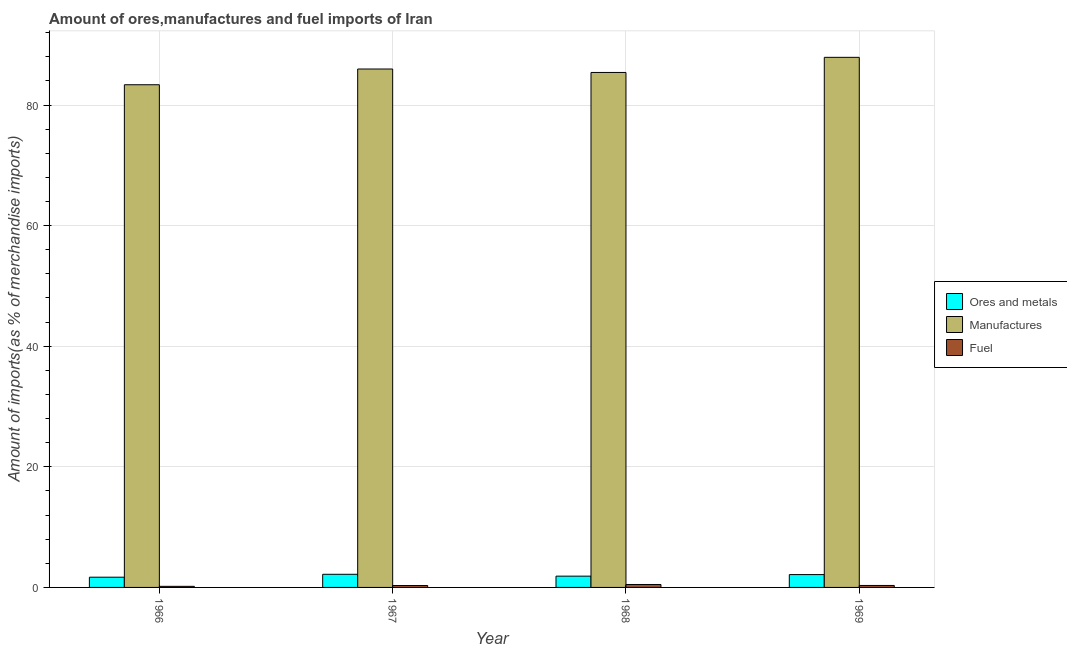How many different coloured bars are there?
Keep it short and to the point. 3. How many bars are there on the 2nd tick from the left?
Your response must be concise. 3. How many bars are there on the 4th tick from the right?
Give a very brief answer. 3. What is the label of the 4th group of bars from the left?
Ensure brevity in your answer.  1969. In how many cases, is the number of bars for a given year not equal to the number of legend labels?
Offer a terse response. 0. What is the percentage of ores and metals imports in 1969?
Ensure brevity in your answer.  2.13. Across all years, what is the maximum percentage of manufactures imports?
Ensure brevity in your answer.  87.91. Across all years, what is the minimum percentage of manufactures imports?
Ensure brevity in your answer.  83.36. In which year was the percentage of fuel imports maximum?
Provide a succinct answer. 1968. In which year was the percentage of manufactures imports minimum?
Your answer should be compact. 1966. What is the total percentage of fuel imports in the graph?
Your answer should be very brief. 1.31. What is the difference between the percentage of ores and metals imports in 1967 and that in 1969?
Make the answer very short. 0.05. What is the difference between the percentage of ores and metals imports in 1967 and the percentage of fuel imports in 1969?
Offer a very short reply. 0.05. What is the average percentage of fuel imports per year?
Give a very brief answer. 0.33. In the year 1966, what is the difference between the percentage of ores and metals imports and percentage of fuel imports?
Ensure brevity in your answer.  0. In how many years, is the percentage of ores and metals imports greater than 4 %?
Your answer should be very brief. 0. What is the ratio of the percentage of ores and metals imports in 1968 to that in 1969?
Offer a very short reply. 0.88. What is the difference between the highest and the second highest percentage of fuel imports?
Provide a succinct answer. 0.16. What is the difference between the highest and the lowest percentage of ores and metals imports?
Make the answer very short. 0.48. Is the sum of the percentage of ores and metals imports in 1966 and 1967 greater than the maximum percentage of fuel imports across all years?
Your answer should be compact. Yes. What does the 1st bar from the left in 1967 represents?
Ensure brevity in your answer.  Ores and metals. What does the 3rd bar from the right in 1968 represents?
Ensure brevity in your answer.  Ores and metals. How many bars are there?
Your answer should be very brief. 12. How many years are there in the graph?
Ensure brevity in your answer.  4. What is the difference between two consecutive major ticks on the Y-axis?
Your response must be concise. 20. Are the values on the major ticks of Y-axis written in scientific E-notation?
Offer a terse response. No. What is the title of the graph?
Provide a succinct answer. Amount of ores,manufactures and fuel imports of Iran. Does "Ireland" appear as one of the legend labels in the graph?
Your answer should be very brief. No. What is the label or title of the X-axis?
Ensure brevity in your answer.  Year. What is the label or title of the Y-axis?
Your answer should be compact. Amount of imports(as % of merchandise imports). What is the Amount of imports(as % of merchandise imports) of Ores and metals in 1966?
Keep it short and to the point. 1.7. What is the Amount of imports(as % of merchandise imports) of Manufactures in 1966?
Give a very brief answer. 83.36. What is the Amount of imports(as % of merchandise imports) in Fuel in 1966?
Provide a short and direct response. 0.18. What is the Amount of imports(as % of merchandise imports) of Ores and metals in 1967?
Your answer should be very brief. 2.18. What is the Amount of imports(as % of merchandise imports) in Manufactures in 1967?
Give a very brief answer. 85.97. What is the Amount of imports(as % of merchandise imports) of Fuel in 1967?
Keep it short and to the point. 0.32. What is the Amount of imports(as % of merchandise imports) of Ores and metals in 1968?
Provide a succinct answer. 1.87. What is the Amount of imports(as % of merchandise imports) of Manufactures in 1968?
Give a very brief answer. 85.4. What is the Amount of imports(as % of merchandise imports) of Fuel in 1968?
Your answer should be compact. 0.49. What is the Amount of imports(as % of merchandise imports) of Ores and metals in 1969?
Ensure brevity in your answer.  2.13. What is the Amount of imports(as % of merchandise imports) in Manufactures in 1969?
Offer a very short reply. 87.91. What is the Amount of imports(as % of merchandise imports) of Fuel in 1969?
Offer a very short reply. 0.33. Across all years, what is the maximum Amount of imports(as % of merchandise imports) of Ores and metals?
Keep it short and to the point. 2.18. Across all years, what is the maximum Amount of imports(as % of merchandise imports) of Manufactures?
Give a very brief answer. 87.91. Across all years, what is the maximum Amount of imports(as % of merchandise imports) of Fuel?
Your answer should be very brief. 0.49. Across all years, what is the minimum Amount of imports(as % of merchandise imports) of Ores and metals?
Provide a succinct answer. 1.7. Across all years, what is the minimum Amount of imports(as % of merchandise imports) of Manufactures?
Give a very brief answer. 83.36. Across all years, what is the minimum Amount of imports(as % of merchandise imports) of Fuel?
Your answer should be compact. 0.18. What is the total Amount of imports(as % of merchandise imports) of Ores and metals in the graph?
Provide a succinct answer. 7.87. What is the total Amount of imports(as % of merchandise imports) in Manufactures in the graph?
Offer a terse response. 342.64. What is the total Amount of imports(as % of merchandise imports) in Fuel in the graph?
Keep it short and to the point. 1.31. What is the difference between the Amount of imports(as % of merchandise imports) of Ores and metals in 1966 and that in 1967?
Give a very brief answer. -0.48. What is the difference between the Amount of imports(as % of merchandise imports) in Manufactures in 1966 and that in 1967?
Keep it short and to the point. -2.61. What is the difference between the Amount of imports(as % of merchandise imports) of Fuel in 1966 and that in 1967?
Your answer should be compact. -0.14. What is the difference between the Amount of imports(as % of merchandise imports) in Ores and metals in 1966 and that in 1968?
Your answer should be very brief. -0.17. What is the difference between the Amount of imports(as % of merchandise imports) in Manufactures in 1966 and that in 1968?
Give a very brief answer. -2.04. What is the difference between the Amount of imports(as % of merchandise imports) of Fuel in 1966 and that in 1968?
Provide a short and direct response. -0.31. What is the difference between the Amount of imports(as % of merchandise imports) in Ores and metals in 1966 and that in 1969?
Keep it short and to the point. -0.43. What is the difference between the Amount of imports(as % of merchandise imports) of Manufactures in 1966 and that in 1969?
Your answer should be compact. -4.55. What is the difference between the Amount of imports(as % of merchandise imports) of Fuel in 1966 and that in 1969?
Your answer should be very brief. -0.15. What is the difference between the Amount of imports(as % of merchandise imports) of Ores and metals in 1967 and that in 1968?
Your response must be concise. 0.31. What is the difference between the Amount of imports(as % of merchandise imports) in Manufactures in 1967 and that in 1968?
Provide a succinct answer. 0.57. What is the difference between the Amount of imports(as % of merchandise imports) in Fuel in 1967 and that in 1968?
Keep it short and to the point. -0.17. What is the difference between the Amount of imports(as % of merchandise imports) of Ores and metals in 1967 and that in 1969?
Your response must be concise. 0.05. What is the difference between the Amount of imports(as % of merchandise imports) in Manufactures in 1967 and that in 1969?
Your answer should be compact. -1.94. What is the difference between the Amount of imports(as % of merchandise imports) in Fuel in 1967 and that in 1969?
Give a very brief answer. -0.01. What is the difference between the Amount of imports(as % of merchandise imports) in Ores and metals in 1968 and that in 1969?
Give a very brief answer. -0.26. What is the difference between the Amount of imports(as % of merchandise imports) of Manufactures in 1968 and that in 1969?
Ensure brevity in your answer.  -2.51. What is the difference between the Amount of imports(as % of merchandise imports) of Fuel in 1968 and that in 1969?
Provide a succinct answer. 0.16. What is the difference between the Amount of imports(as % of merchandise imports) in Ores and metals in 1966 and the Amount of imports(as % of merchandise imports) in Manufactures in 1967?
Your answer should be very brief. -84.27. What is the difference between the Amount of imports(as % of merchandise imports) in Ores and metals in 1966 and the Amount of imports(as % of merchandise imports) in Fuel in 1967?
Keep it short and to the point. 1.38. What is the difference between the Amount of imports(as % of merchandise imports) in Manufactures in 1966 and the Amount of imports(as % of merchandise imports) in Fuel in 1967?
Your response must be concise. 83.04. What is the difference between the Amount of imports(as % of merchandise imports) of Ores and metals in 1966 and the Amount of imports(as % of merchandise imports) of Manufactures in 1968?
Your answer should be compact. -83.7. What is the difference between the Amount of imports(as % of merchandise imports) of Ores and metals in 1966 and the Amount of imports(as % of merchandise imports) of Fuel in 1968?
Your response must be concise. 1.21. What is the difference between the Amount of imports(as % of merchandise imports) in Manufactures in 1966 and the Amount of imports(as % of merchandise imports) in Fuel in 1968?
Make the answer very short. 82.87. What is the difference between the Amount of imports(as % of merchandise imports) in Ores and metals in 1966 and the Amount of imports(as % of merchandise imports) in Manufactures in 1969?
Your response must be concise. -86.21. What is the difference between the Amount of imports(as % of merchandise imports) of Ores and metals in 1966 and the Amount of imports(as % of merchandise imports) of Fuel in 1969?
Give a very brief answer. 1.37. What is the difference between the Amount of imports(as % of merchandise imports) of Manufactures in 1966 and the Amount of imports(as % of merchandise imports) of Fuel in 1969?
Provide a succinct answer. 83.03. What is the difference between the Amount of imports(as % of merchandise imports) of Ores and metals in 1967 and the Amount of imports(as % of merchandise imports) of Manufactures in 1968?
Keep it short and to the point. -83.22. What is the difference between the Amount of imports(as % of merchandise imports) in Ores and metals in 1967 and the Amount of imports(as % of merchandise imports) in Fuel in 1968?
Offer a very short reply. 1.69. What is the difference between the Amount of imports(as % of merchandise imports) in Manufactures in 1967 and the Amount of imports(as % of merchandise imports) in Fuel in 1968?
Provide a short and direct response. 85.48. What is the difference between the Amount of imports(as % of merchandise imports) in Ores and metals in 1967 and the Amount of imports(as % of merchandise imports) in Manufactures in 1969?
Provide a succinct answer. -85.73. What is the difference between the Amount of imports(as % of merchandise imports) in Ores and metals in 1967 and the Amount of imports(as % of merchandise imports) in Fuel in 1969?
Your answer should be very brief. 1.85. What is the difference between the Amount of imports(as % of merchandise imports) in Manufactures in 1967 and the Amount of imports(as % of merchandise imports) in Fuel in 1969?
Ensure brevity in your answer.  85.64. What is the difference between the Amount of imports(as % of merchandise imports) in Ores and metals in 1968 and the Amount of imports(as % of merchandise imports) in Manufactures in 1969?
Keep it short and to the point. -86.04. What is the difference between the Amount of imports(as % of merchandise imports) in Ores and metals in 1968 and the Amount of imports(as % of merchandise imports) in Fuel in 1969?
Give a very brief answer. 1.54. What is the difference between the Amount of imports(as % of merchandise imports) in Manufactures in 1968 and the Amount of imports(as % of merchandise imports) in Fuel in 1969?
Keep it short and to the point. 85.07. What is the average Amount of imports(as % of merchandise imports) in Ores and metals per year?
Provide a succinct answer. 1.97. What is the average Amount of imports(as % of merchandise imports) of Manufactures per year?
Provide a short and direct response. 85.66. What is the average Amount of imports(as % of merchandise imports) in Fuel per year?
Your answer should be very brief. 0.33. In the year 1966, what is the difference between the Amount of imports(as % of merchandise imports) in Ores and metals and Amount of imports(as % of merchandise imports) in Manufactures?
Provide a short and direct response. -81.66. In the year 1966, what is the difference between the Amount of imports(as % of merchandise imports) in Ores and metals and Amount of imports(as % of merchandise imports) in Fuel?
Make the answer very short. 1.52. In the year 1966, what is the difference between the Amount of imports(as % of merchandise imports) of Manufactures and Amount of imports(as % of merchandise imports) of Fuel?
Your answer should be compact. 83.18. In the year 1967, what is the difference between the Amount of imports(as % of merchandise imports) in Ores and metals and Amount of imports(as % of merchandise imports) in Manufactures?
Provide a succinct answer. -83.79. In the year 1967, what is the difference between the Amount of imports(as % of merchandise imports) in Ores and metals and Amount of imports(as % of merchandise imports) in Fuel?
Your answer should be compact. 1.86. In the year 1967, what is the difference between the Amount of imports(as % of merchandise imports) of Manufactures and Amount of imports(as % of merchandise imports) of Fuel?
Offer a very short reply. 85.65. In the year 1968, what is the difference between the Amount of imports(as % of merchandise imports) in Ores and metals and Amount of imports(as % of merchandise imports) in Manufactures?
Offer a very short reply. -83.53. In the year 1968, what is the difference between the Amount of imports(as % of merchandise imports) of Ores and metals and Amount of imports(as % of merchandise imports) of Fuel?
Give a very brief answer. 1.38. In the year 1968, what is the difference between the Amount of imports(as % of merchandise imports) of Manufactures and Amount of imports(as % of merchandise imports) of Fuel?
Offer a terse response. 84.91. In the year 1969, what is the difference between the Amount of imports(as % of merchandise imports) in Ores and metals and Amount of imports(as % of merchandise imports) in Manufactures?
Your response must be concise. -85.78. In the year 1969, what is the difference between the Amount of imports(as % of merchandise imports) in Ores and metals and Amount of imports(as % of merchandise imports) in Fuel?
Offer a terse response. 1.8. In the year 1969, what is the difference between the Amount of imports(as % of merchandise imports) in Manufactures and Amount of imports(as % of merchandise imports) in Fuel?
Make the answer very short. 87.58. What is the ratio of the Amount of imports(as % of merchandise imports) of Ores and metals in 1966 to that in 1967?
Give a very brief answer. 0.78. What is the ratio of the Amount of imports(as % of merchandise imports) in Manufactures in 1966 to that in 1967?
Ensure brevity in your answer.  0.97. What is the ratio of the Amount of imports(as % of merchandise imports) of Fuel in 1966 to that in 1967?
Offer a very short reply. 0.56. What is the ratio of the Amount of imports(as % of merchandise imports) in Ores and metals in 1966 to that in 1968?
Give a very brief answer. 0.91. What is the ratio of the Amount of imports(as % of merchandise imports) of Manufactures in 1966 to that in 1968?
Your answer should be compact. 0.98. What is the ratio of the Amount of imports(as % of merchandise imports) in Fuel in 1966 to that in 1968?
Keep it short and to the point. 0.37. What is the ratio of the Amount of imports(as % of merchandise imports) in Ores and metals in 1966 to that in 1969?
Your answer should be compact. 0.8. What is the ratio of the Amount of imports(as % of merchandise imports) of Manufactures in 1966 to that in 1969?
Provide a succinct answer. 0.95. What is the ratio of the Amount of imports(as % of merchandise imports) of Fuel in 1966 to that in 1969?
Your response must be concise. 0.55. What is the ratio of the Amount of imports(as % of merchandise imports) in Ores and metals in 1967 to that in 1968?
Make the answer very short. 1.17. What is the ratio of the Amount of imports(as % of merchandise imports) of Manufactures in 1967 to that in 1968?
Offer a very short reply. 1.01. What is the ratio of the Amount of imports(as % of merchandise imports) of Fuel in 1967 to that in 1968?
Your response must be concise. 0.66. What is the ratio of the Amount of imports(as % of merchandise imports) of Ores and metals in 1968 to that in 1969?
Make the answer very short. 0.88. What is the ratio of the Amount of imports(as % of merchandise imports) of Manufactures in 1968 to that in 1969?
Your response must be concise. 0.97. What is the ratio of the Amount of imports(as % of merchandise imports) of Fuel in 1968 to that in 1969?
Provide a short and direct response. 1.49. What is the difference between the highest and the second highest Amount of imports(as % of merchandise imports) in Ores and metals?
Give a very brief answer. 0.05. What is the difference between the highest and the second highest Amount of imports(as % of merchandise imports) in Manufactures?
Your response must be concise. 1.94. What is the difference between the highest and the second highest Amount of imports(as % of merchandise imports) of Fuel?
Keep it short and to the point. 0.16. What is the difference between the highest and the lowest Amount of imports(as % of merchandise imports) in Ores and metals?
Provide a succinct answer. 0.48. What is the difference between the highest and the lowest Amount of imports(as % of merchandise imports) in Manufactures?
Your answer should be compact. 4.55. What is the difference between the highest and the lowest Amount of imports(as % of merchandise imports) of Fuel?
Your response must be concise. 0.31. 